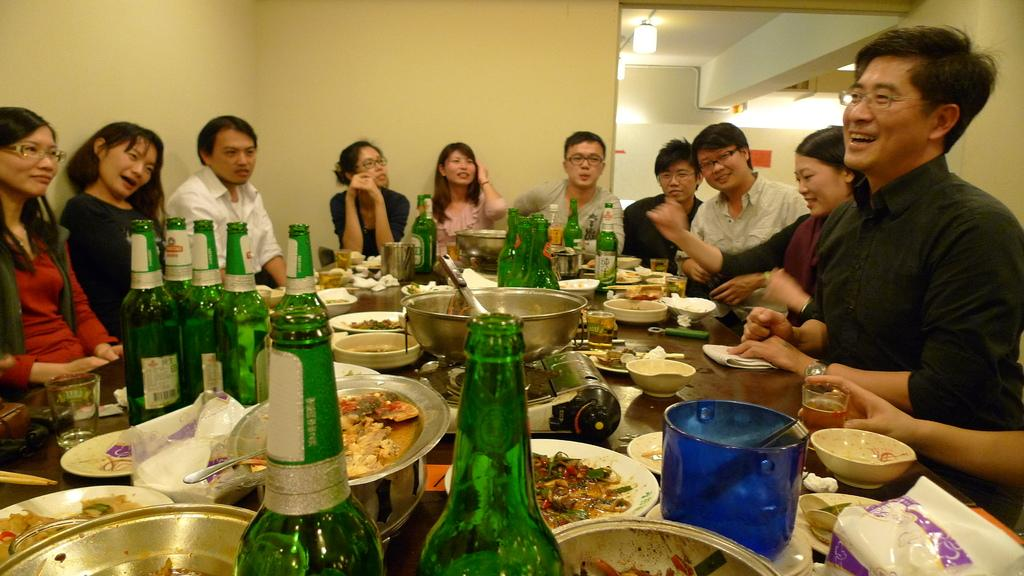How many people are in the image? There is a group of persons in the image. What are the persons doing in the image? The persons are sitting around a table. What can be seen on the table in the image? There are eatables and drink bottles on the table. What type of linen is draped over the table in the image? There is no linen draped over the table in the image. Can you see a rat running across the table in the image? There is no rat present in the image. 